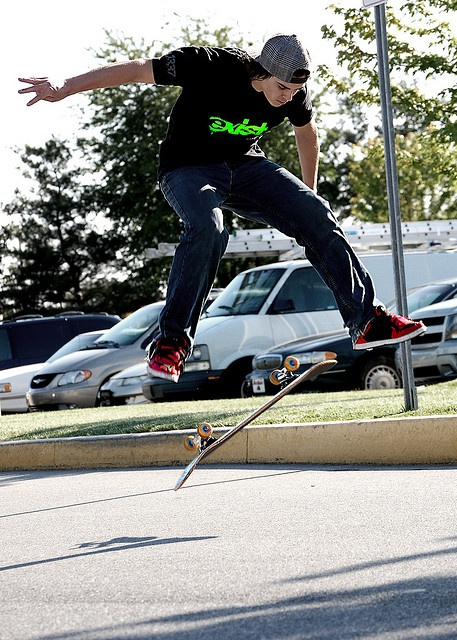Describe the objects in this image and their specific colors. I can see people in white, black, and gray tones, truck in white, black, lightblue, and darkgray tones, car in white, black, darkgray, gray, and lightgray tones, car in white, black, darkgray, and gray tones, and car in white, black, navy, gray, and darkblue tones in this image. 